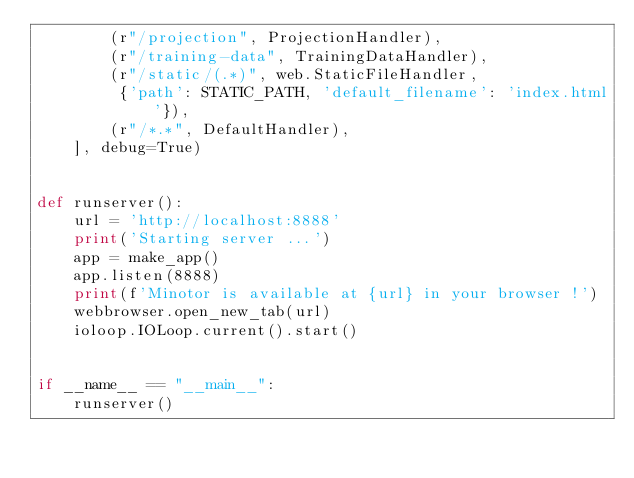<code> <loc_0><loc_0><loc_500><loc_500><_Python_>        (r"/projection", ProjectionHandler),
        (r"/training-data", TrainingDataHandler),
        (r"/static/(.*)", web.StaticFileHandler,
         {'path': STATIC_PATH, 'default_filename': 'index.html'}),
        (r"/*.*", DefaultHandler),
    ], debug=True)


def runserver():
    url = 'http://localhost:8888'
    print('Starting server ...')
    app = make_app()
    app.listen(8888)
    print(f'Minotor is available at {url} in your browser !')
    webbrowser.open_new_tab(url)
    ioloop.IOLoop.current().start()


if __name__ == "__main__":
    runserver()
</code> 